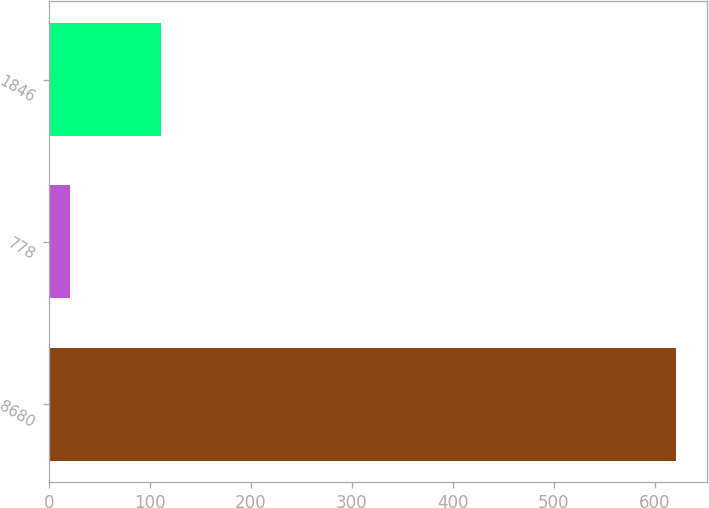<chart> <loc_0><loc_0><loc_500><loc_500><bar_chart><fcel>8680<fcel>778<fcel>1846<nl><fcel>621<fcel>21<fcel>111<nl></chart> 